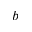Convert formula to latex. <formula><loc_0><loc_0><loc_500><loc_500>^ { b }</formula> 